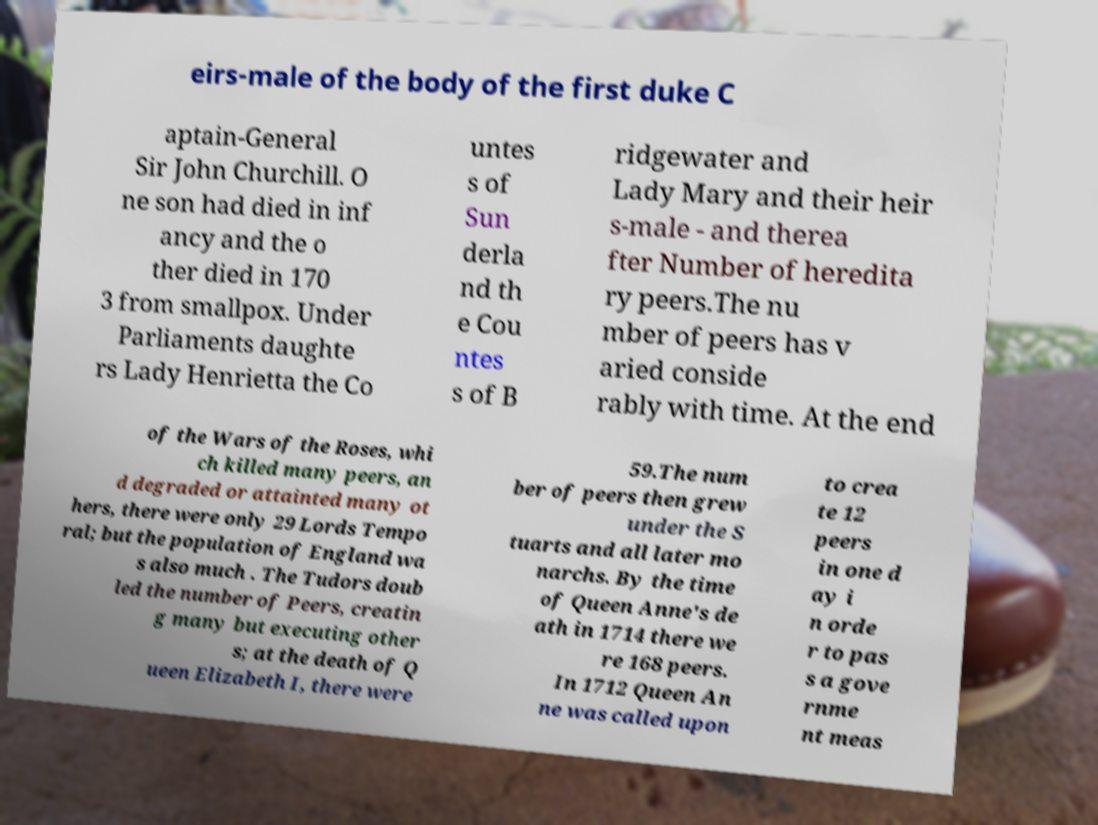Can you read and provide the text displayed in the image?This photo seems to have some interesting text. Can you extract and type it out for me? eirs-male of the body of the first duke C aptain-General Sir John Churchill. O ne son had died in inf ancy and the o ther died in 170 3 from smallpox. Under Parliaments daughte rs Lady Henrietta the Co untes s of Sun derla nd th e Cou ntes s of B ridgewater and Lady Mary and their heir s-male - and therea fter Number of heredita ry peers.The nu mber of peers has v aried conside rably with time. At the end of the Wars of the Roses, whi ch killed many peers, an d degraded or attainted many ot hers, there were only 29 Lords Tempo ral; but the population of England wa s also much . The Tudors doub led the number of Peers, creatin g many but executing other s; at the death of Q ueen Elizabeth I, there were 59.The num ber of peers then grew under the S tuarts and all later mo narchs. By the time of Queen Anne's de ath in 1714 there we re 168 peers. In 1712 Queen An ne was called upon to crea te 12 peers in one d ay i n orde r to pas s a gove rnme nt meas 